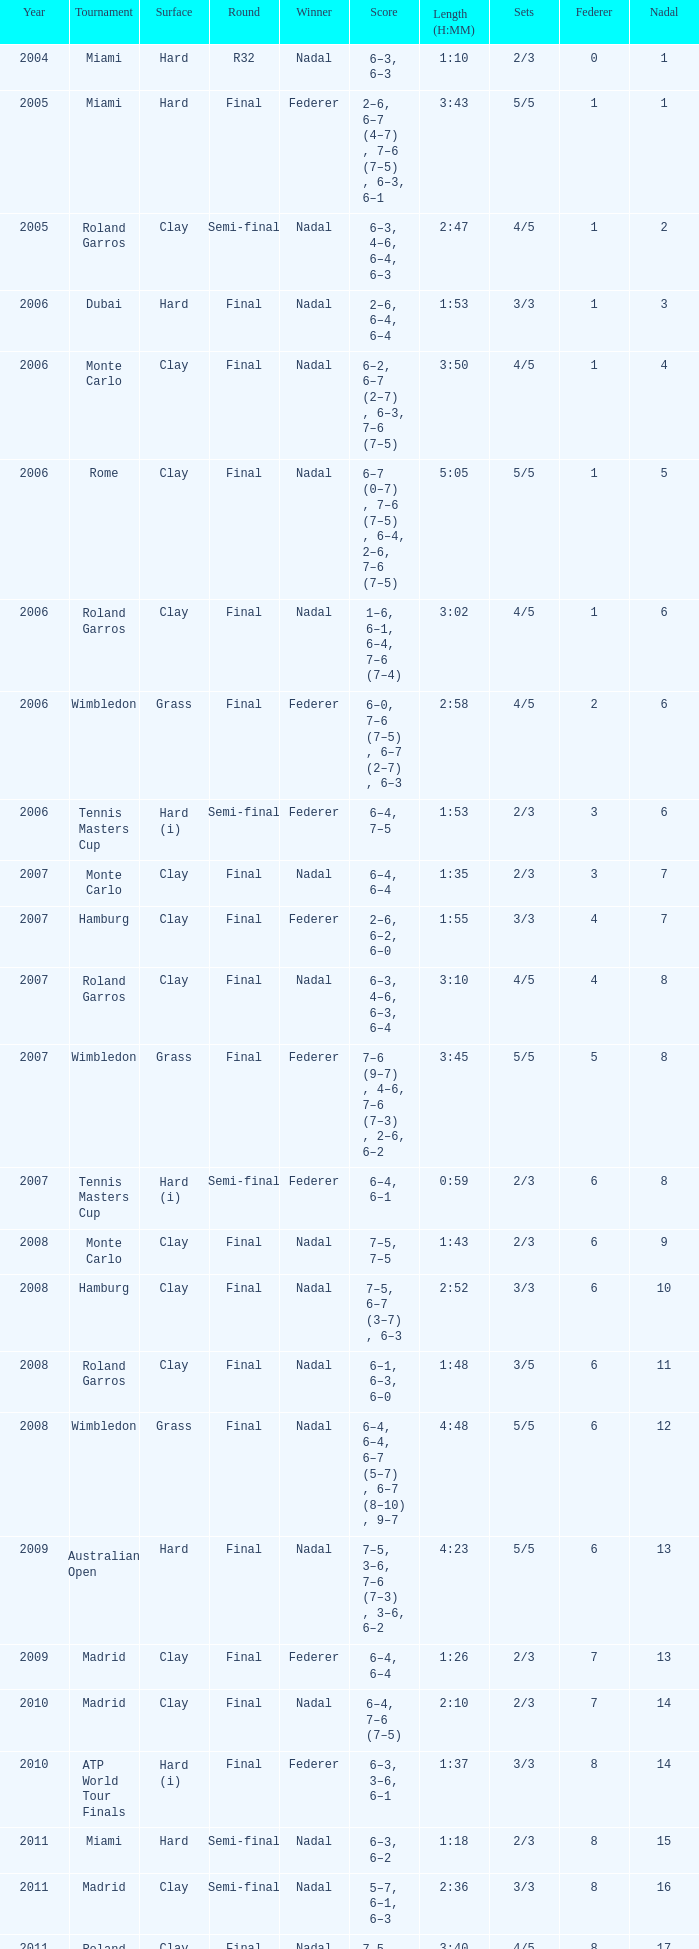What was the lowest point in miami at the last round? 1.0. 